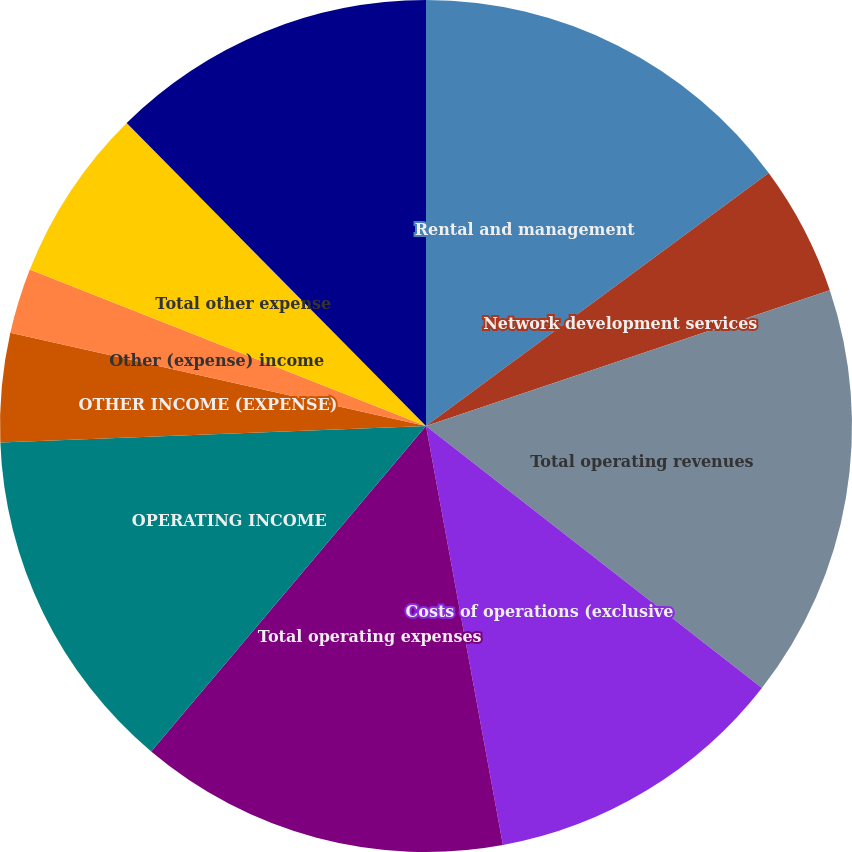Convert chart. <chart><loc_0><loc_0><loc_500><loc_500><pie_chart><fcel>Rental and management<fcel>Network development services<fcel>Total operating revenues<fcel>Costs of operations (exclusive<fcel>Total operating expenses<fcel>OPERATING INCOME<fcel>OTHER INCOME (EXPENSE)<fcel>Other (expense) income<fcel>Total other expense<fcel>INCOME FROM CONTINUING<nl><fcel>14.88%<fcel>4.96%<fcel>15.7%<fcel>11.57%<fcel>14.05%<fcel>13.22%<fcel>4.13%<fcel>2.48%<fcel>6.61%<fcel>12.4%<nl></chart> 